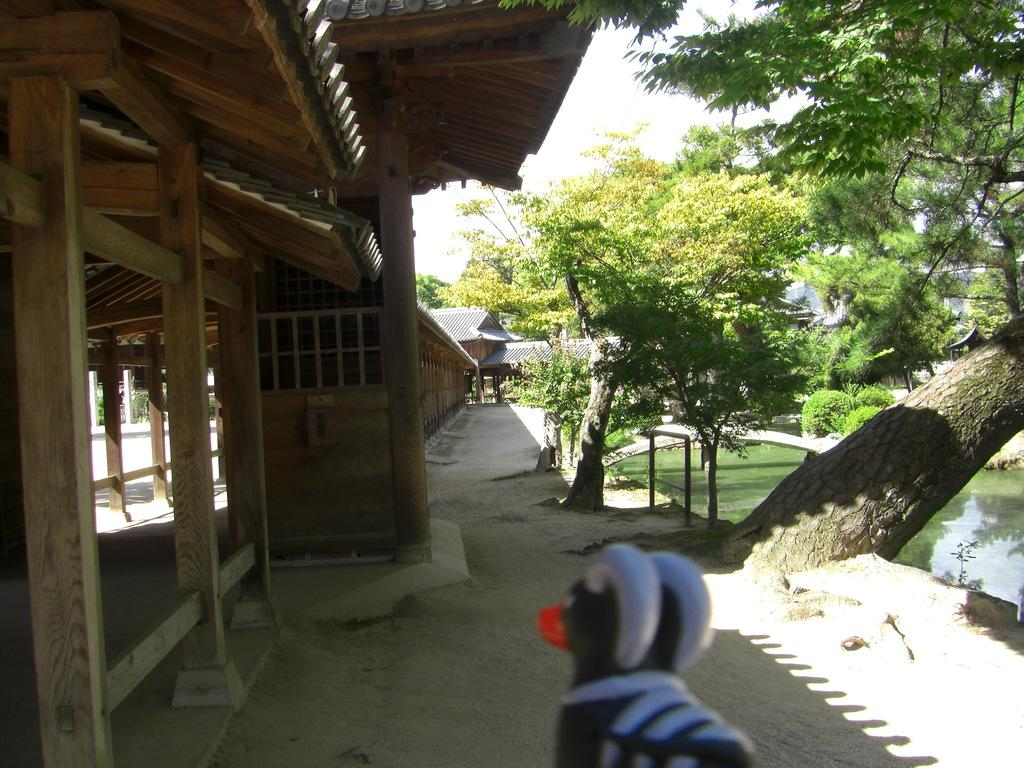What type of structure is depicted in the image? There is a building with wooden pillars in the image. What natural elements can be seen in the image? There are trees and water visible in the image. What man-made feature connects two areas in the image? There is a bridge in the image. What additional object is present at the bottom of the image? There is a statue at the bottom of the image. What type of trade is being conducted on the bridge in the image? There is no indication of trade being conducted in the image; it simply shows a bridge connecting two areas. 